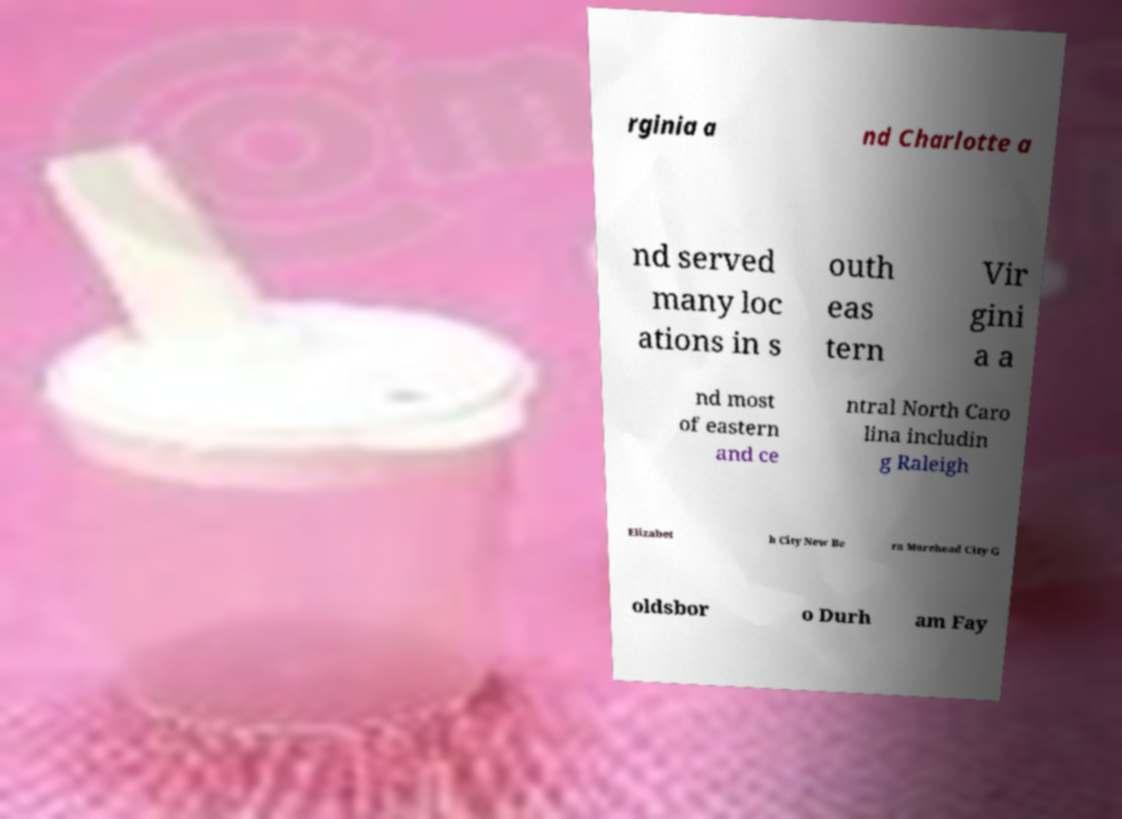Please read and relay the text visible in this image. What does it say? rginia a nd Charlotte a nd served many loc ations in s outh eas tern Vir gini a a nd most of eastern and ce ntral North Caro lina includin g Raleigh Elizabet h City New Be rn Morehead City G oldsbor o Durh am Fay 